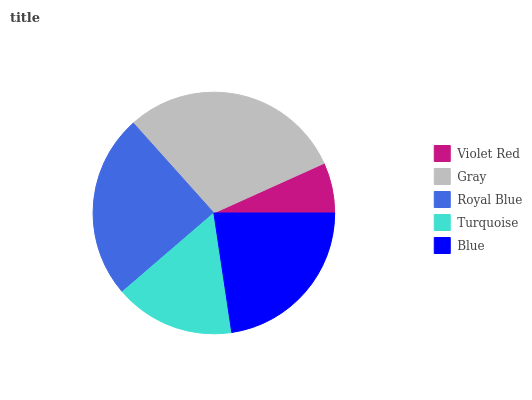Is Violet Red the minimum?
Answer yes or no. Yes. Is Gray the maximum?
Answer yes or no. Yes. Is Royal Blue the minimum?
Answer yes or no. No. Is Royal Blue the maximum?
Answer yes or no. No. Is Gray greater than Royal Blue?
Answer yes or no. Yes. Is Royal Blue less than Gray?
Answer yes or no. Yes. Is Royal Blue greater than Gray?
Answer yes or no. No. Is Gray less than Royal Blue?
Answer yes or no. No. Is Blue the high median?
Answer yes or no. Yes. Is Blue the low median?
Answer yes or no. Yes. Is Violet Red the high median?
Answer yes or no. No. Is Gray the low median?
Answer yes or no. No. 